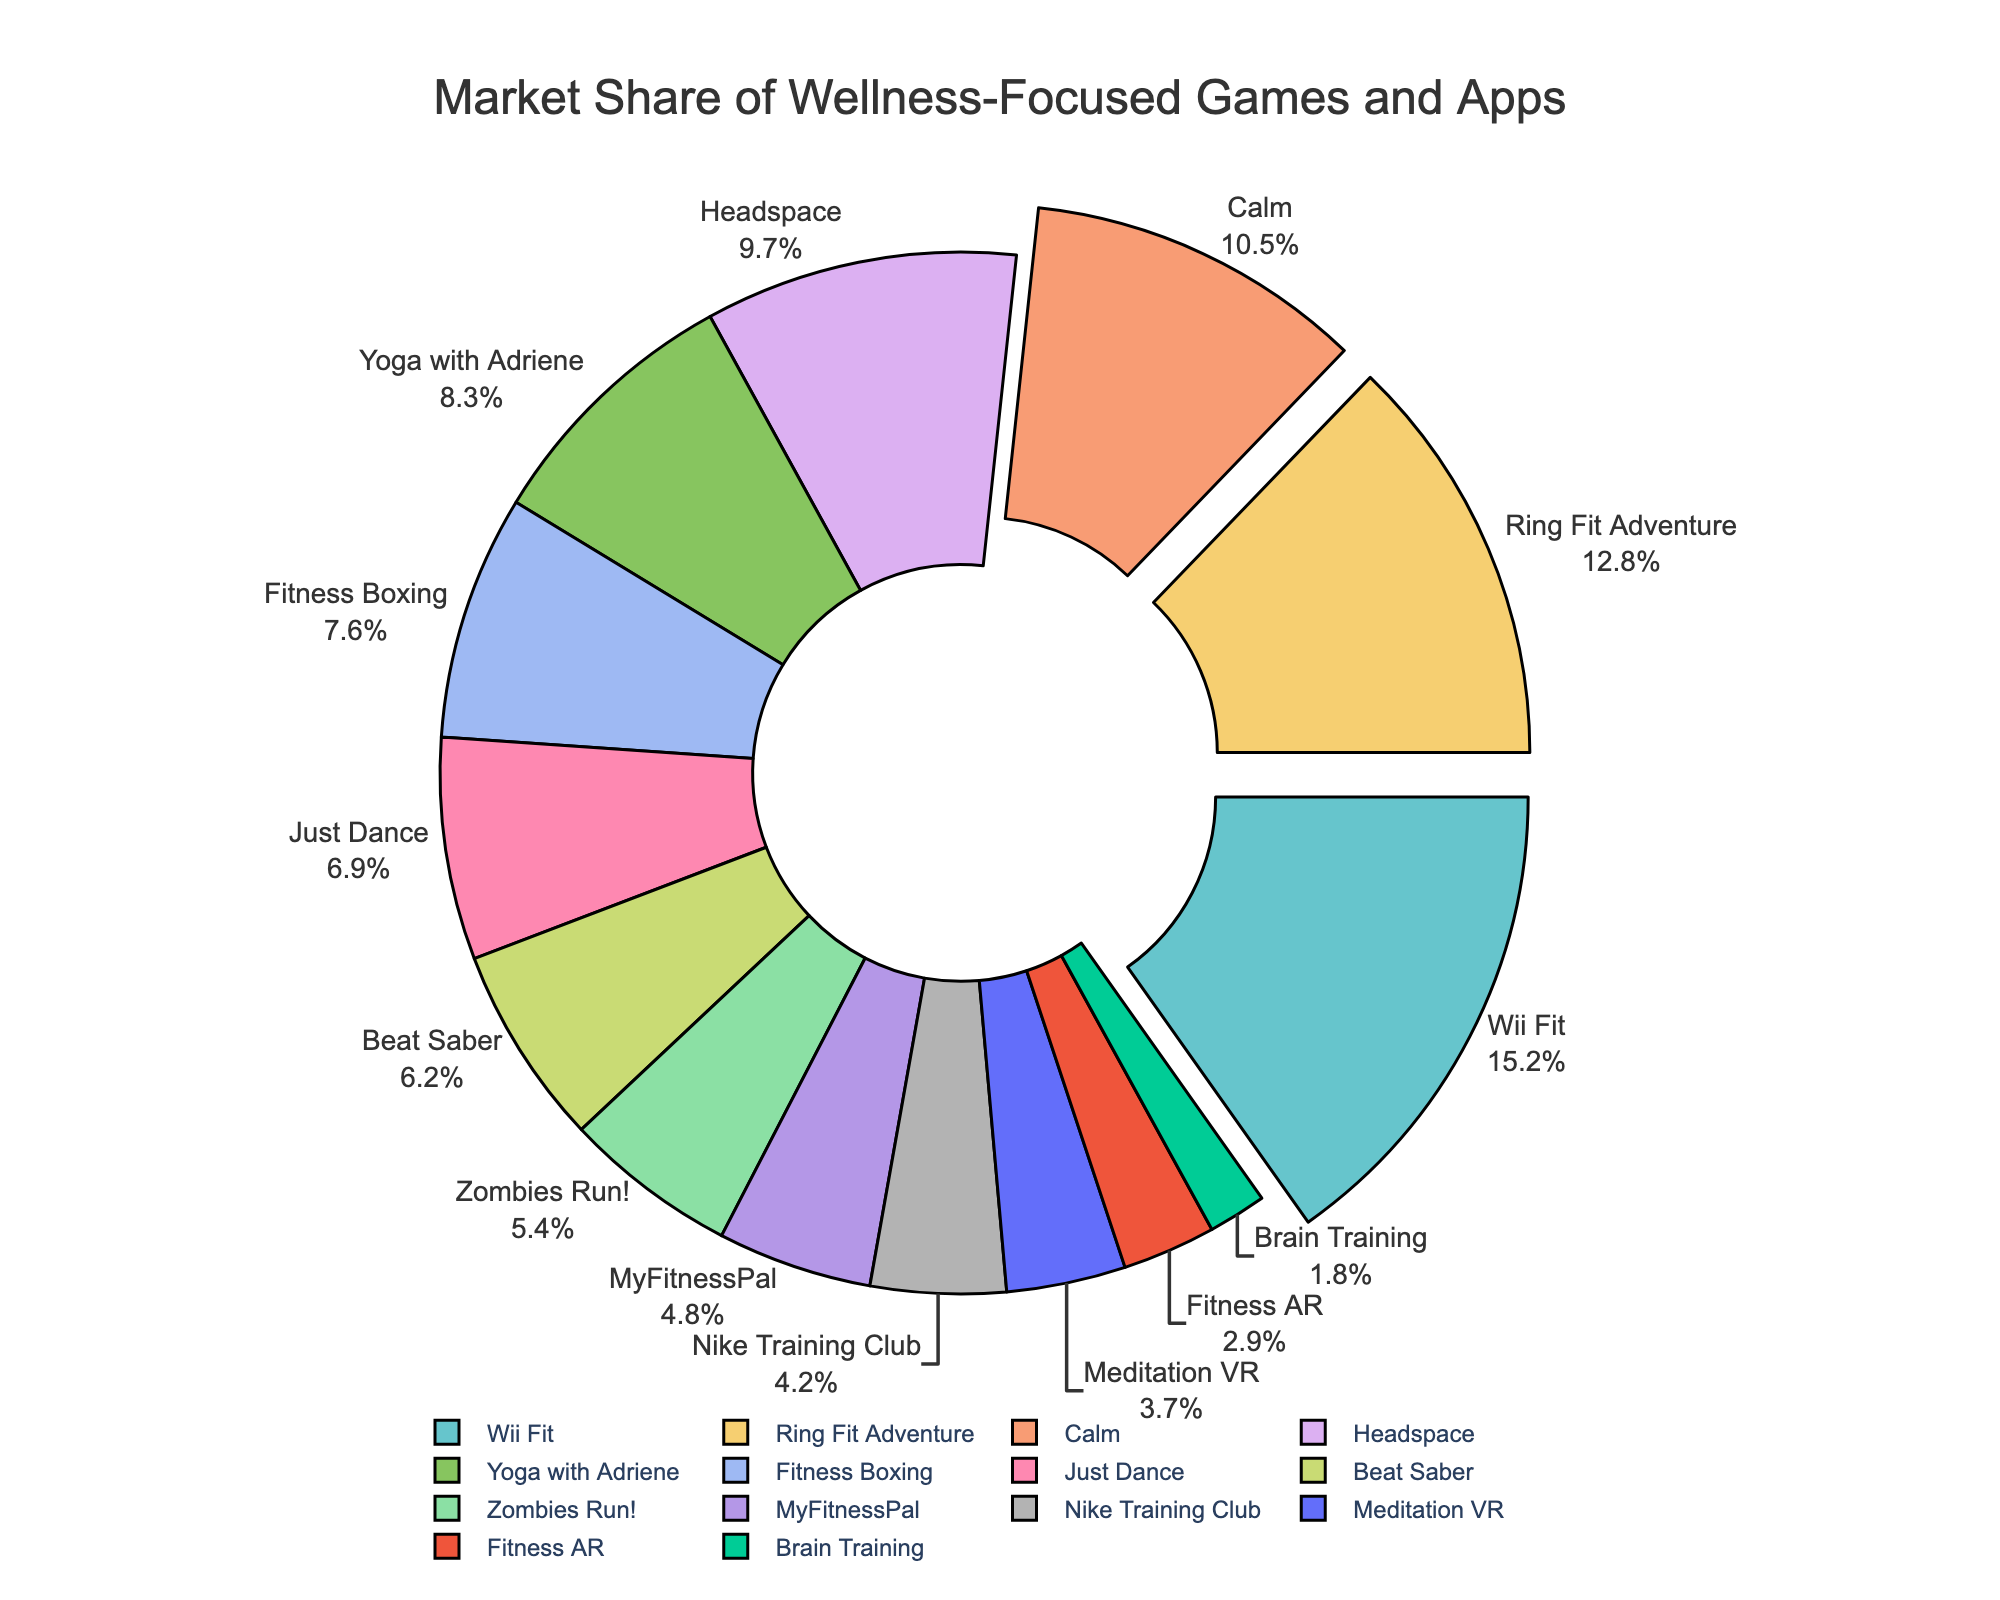What are the top three wellness-focused games and apps by market share? To identify the top three, look for the ones with the highest percentage share. The three largest segments pulled away from the pie chart represent the top shares: Wii Fit (15.2%), Ring Fit Adventure (12.8%), and Calm (10.5%).
Answer: Wii Fit, Ring Fit Adventure, Calm Which has a higher market share, Just Dance or Beat Saber? Compare the percentages of Just Dance and Beat Saber. Just Dance has 6.9%, while Beat Saber has 6.2%. Just Dance has the higher percentage.
Answer: Just Dance What is the combined market share of MyFitnessPal and Nike Training Club? Sum the shares of MyFitnessPal (4.8%) and Nike Training Club (4.2%). 4.8 + 4.2 = 9.0.
Answer: 9.0% Which app has the smallest market share? Identify the segment with the lowest percentage. Brain Training has the smallest market share with 1.8%.
Answer: Brain Training Is the market share of Headspace greater than the combined market share of Meditation VR and Fitness AR? Calculate the combined market share of Meditation VR (3.7%) and Fitness AR (2.9%), which equals 6.6%. Compare it with Headspace's share (9.7%). Headspace's market share is greater.
Answer: Yes What is the difference in market shares between Yoga with Adriene and Fitness Boxing? Subtract the market share of Fitness Boxing (7.6%) from that of Yoga with Adriene (8.3%). 8.3 - 7.6 = 0.7.
Answer: 0.7% Which three apps/games have market shares between 7% and 10%? Identify the segments with market shares in this range. The relevant segments are Headspace (9.7%), Yoga with Adriene (8.3%), and Fitness Boxing (7.6%).
Answer: Headspace, Yoga with Adriene, Fitness Boxing If you combine the market shares of all apps/games with less than 5%, does their total market share exceed that of Calm? Sum the shares of those under 5%: Zombies Run! (5.4%), MyFitnessPal (4.8%), Nike Training Club (4.2%), Meditation VR (3.7%), Fitness AR (2.9%), Brain Training (1.8%). The total is 5.4 + 4.8 + 4.2 + 3.7 + 2.9 + 1.8 = 22.8%. Compare this to Calm (10.5%). The combined market share is indeed greater.
Answer: Yes What is the average market share of the top five wellness-focused games and apps? Identify the top five: Wii Fit (15.2%), Ring Fit Adventure (12.8%), Calm (10.5%), Headspace (9.7%), Yoga with Adriene (8.3%). Sum these shares: 15.2 + 12.8 + 10.5 + 9.7 + 8.3 = 56.5%. Average is 56.5/5 = 11.3%.
Answer: 11.3% 